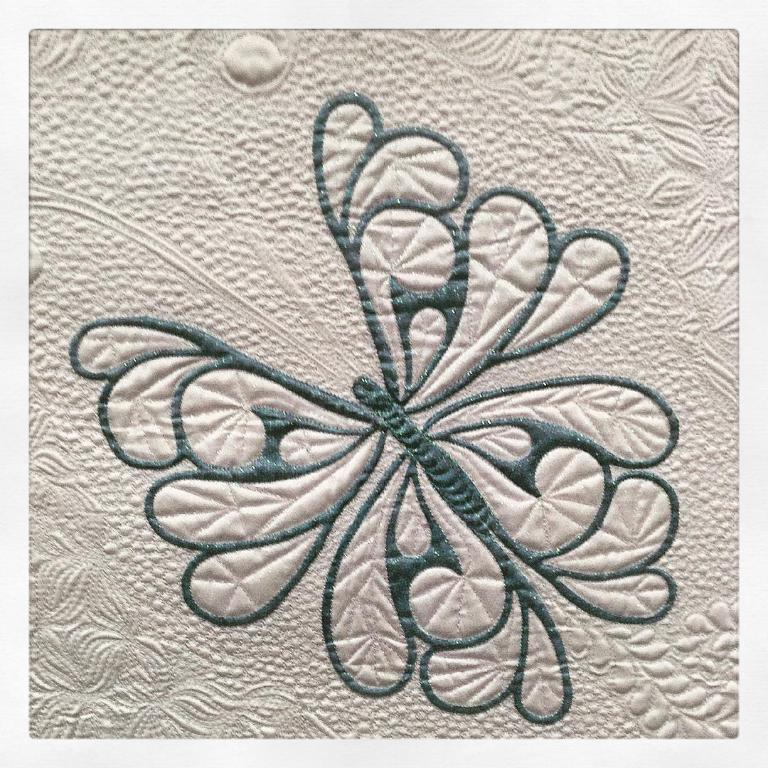What can be seen on the surface in the image? There is a design on a surface in the image. What type of dress is the person wearing in the image? A: There is no person or dress present in the image; it only features a design on a surface. 